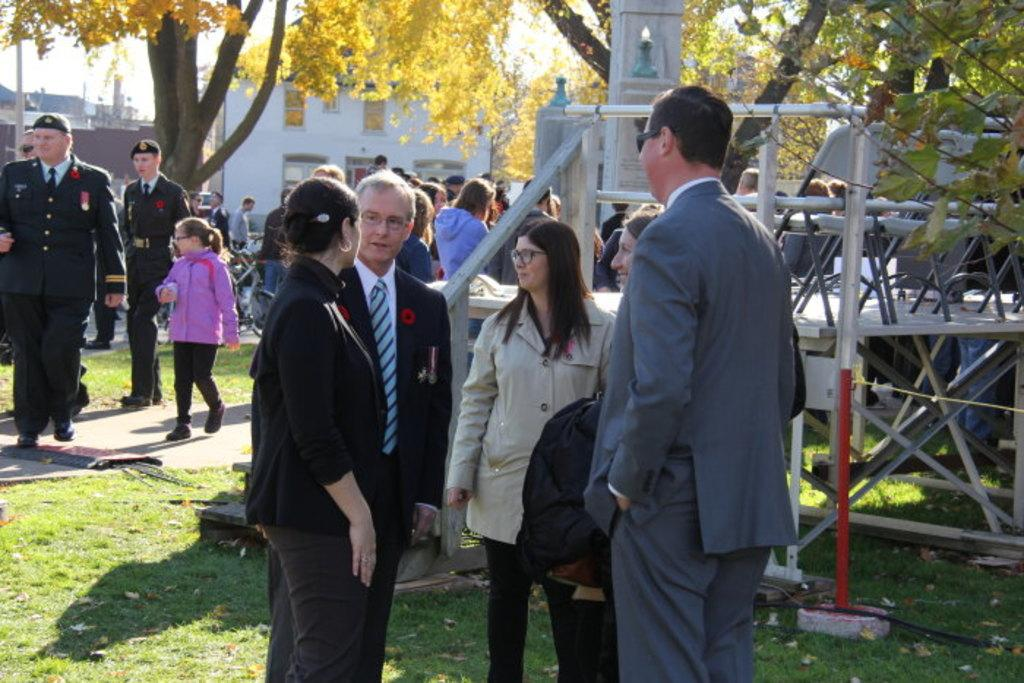How many people are in the image? There are people in the image, but the exact number is not specified. What type of terrain is visible in the image? There is grass in the image, which suggests a natural setting. What kind of path is present in the image? There is a path in the image, which might be used for walking or biking. What safety feature can be seen in the image? There are railings in the image, which might be used to prevent falls or accidents. What type of vegetation is present in the image? There are trees in the image, which adds to the natural setting. What mode of transportation is visible in the image? There is a bicycle in the image, which might be used for transportation or recreation. What structures can be seen in the background of the image? There are buildings in the background of the image, which suggests an urban or suburban setting. What is visible in the sky in the image? The sky is visible in the background of the image, which provides information about the weather or time of day. How many pins are holding up the island in the image? There is no island present in the image, so there are no pins holding it up. What type of offer is being made by the trees in the image? There are no offers being made by the trees in the image; they are simply trees in a natural setting. 